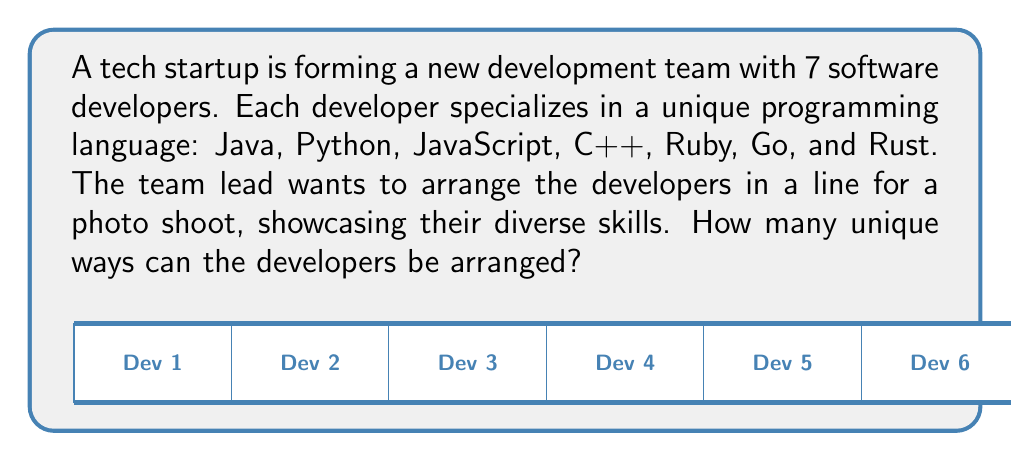Provide a solution to this math problem. Let's approach this step-by-step:

1) This is a permutation problem. We need to arrange 7 distinct developers in a line.

2) In permutation problems, the order matters. Each unique arrangement is a different permutation.

3) For the first position, we have 7 choices (any of the 7 developers can be first).

4) After placing the first developer, we have 6 choices for the second position.

5) For the third position, we have 5 choices, and so on.

6) This pattern continues until we place the last developer, for which we have only 1 choice.

7) The total number of permutations is the product of all these choices:

   $$7 \times 6 \times 5 \times 4 \times 3 \times 2 \times 1$$

8) This product is known as 7 factorial, denoted as $7!$

9) We can calculate this:
   $$7! = 7 \times 6 \times 5 \times 4 \times 3 \times 2 \times 1 = 5040$$

Therefore, there are 5040 unique ways to arrange the 7 developers in a line.
Answer: $7! = 5040$ 